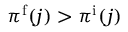Convert formula to latex. <formula><loc_0><loc_0><loc_500><loc_500>\pi ^ { \mathrm f } ( j ) > \pi ^ { \mathrm i } ( j )</formula> 